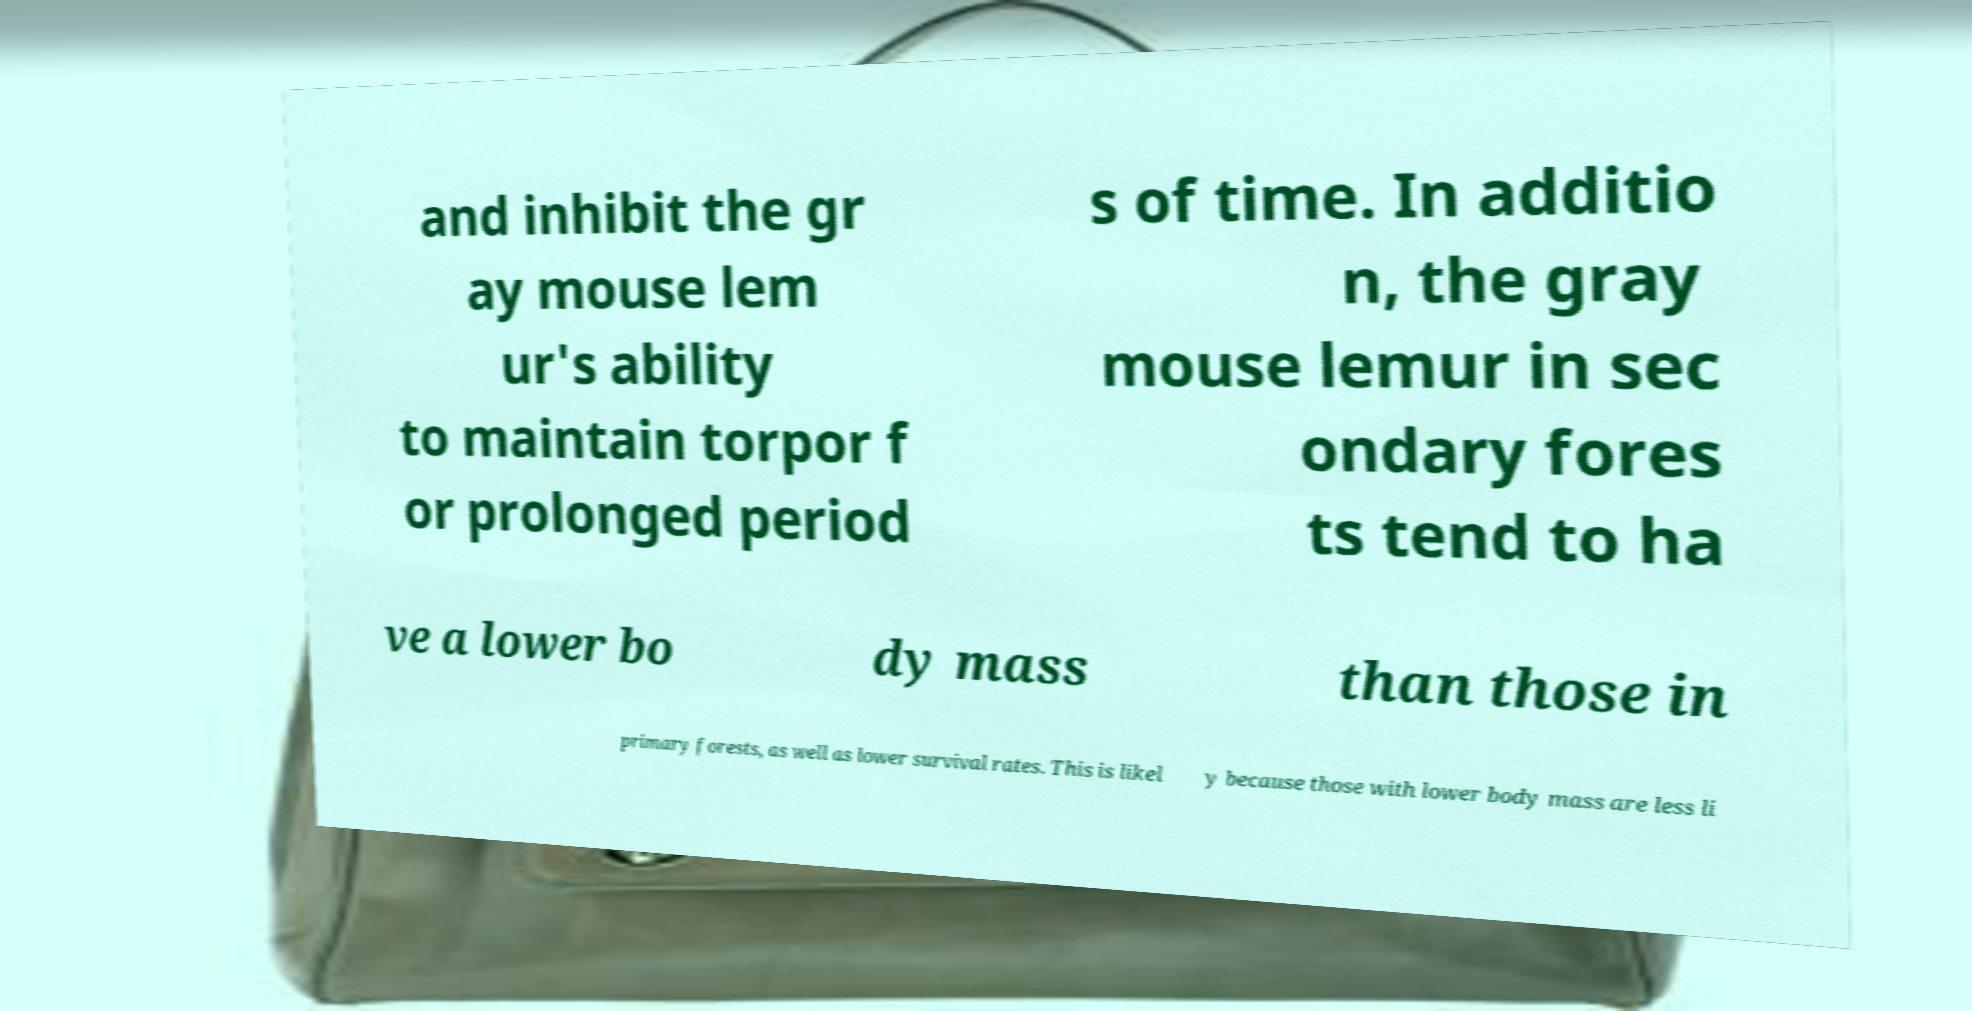For documentation purposes, I need the text within this image transcribed. Could you provide that? and inhibit the gr ay mouse lem ur's ability to maintain torpor f or prolonged period s of time. In additio n, the gray mouse lemur in sec ondary fores ts tend to ha ve a lower bo dy mass than those in primary forests, as well as lower survival rates. This is likel y because those with lower body mass are less li 